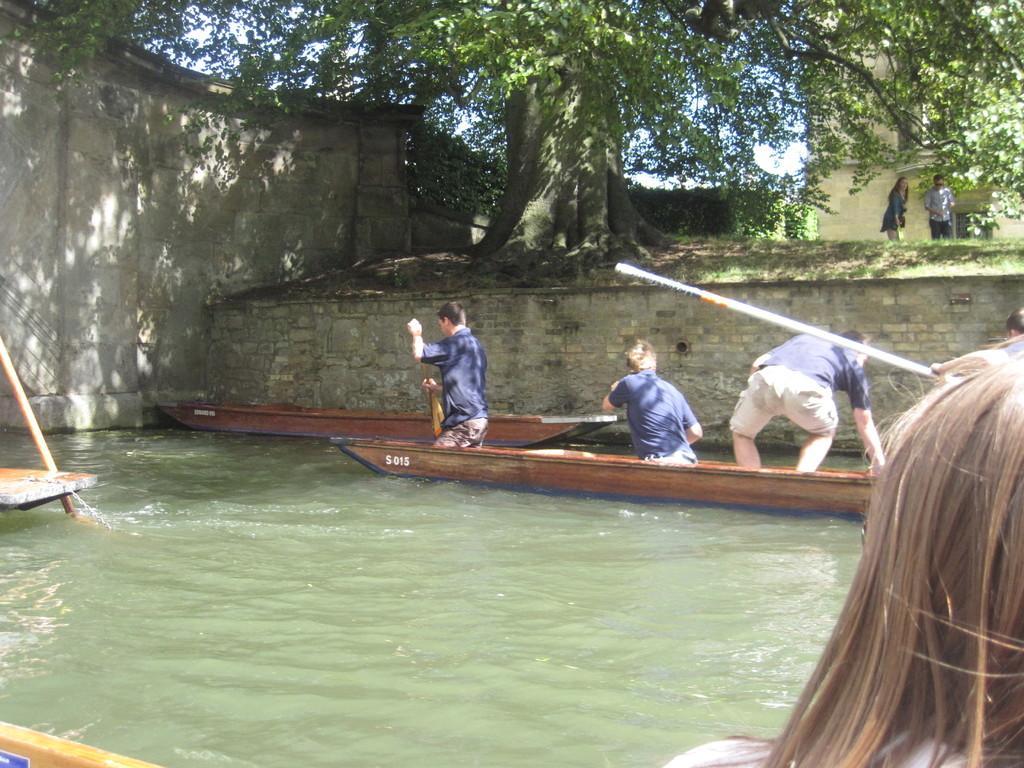Could you give a brief overview of what you see in this image? In this image there is water and we can see boards on the water. There are people in the boats. In the background there is a building and a tree. On the left there is a wall. We can see people standing. There is sky. 